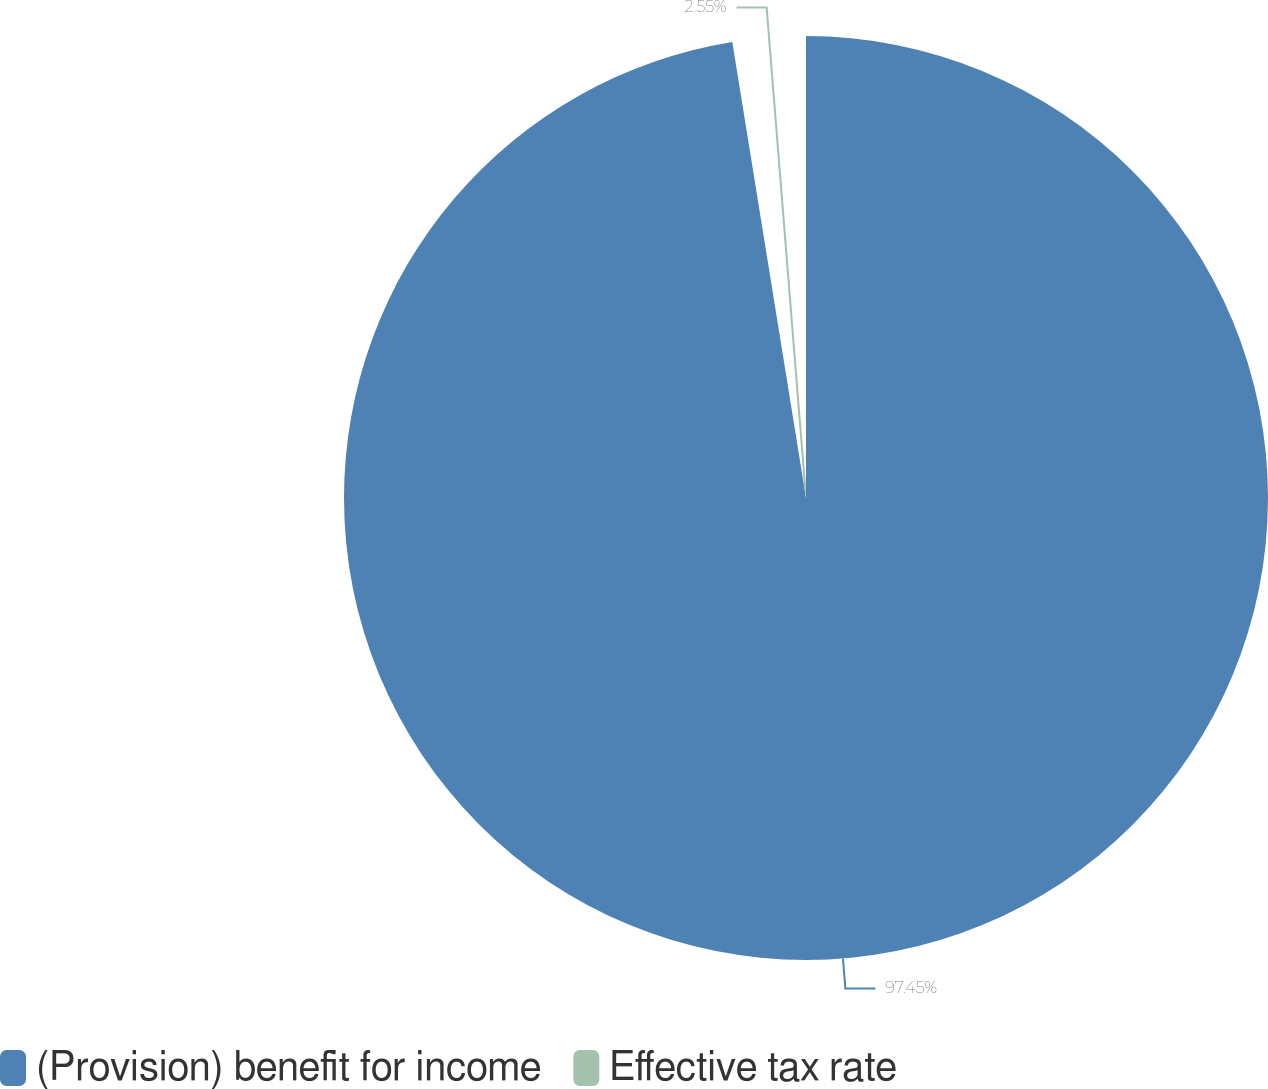Convert chart to OTSL. <chart><loc_0><loc_0><loc_500><loc_500><pie_chart><fcel>(Provision) benefit for income<fcel>Effective tax rate<nl><fcel>97.45%<fcel>2.55%<nl></chart> 